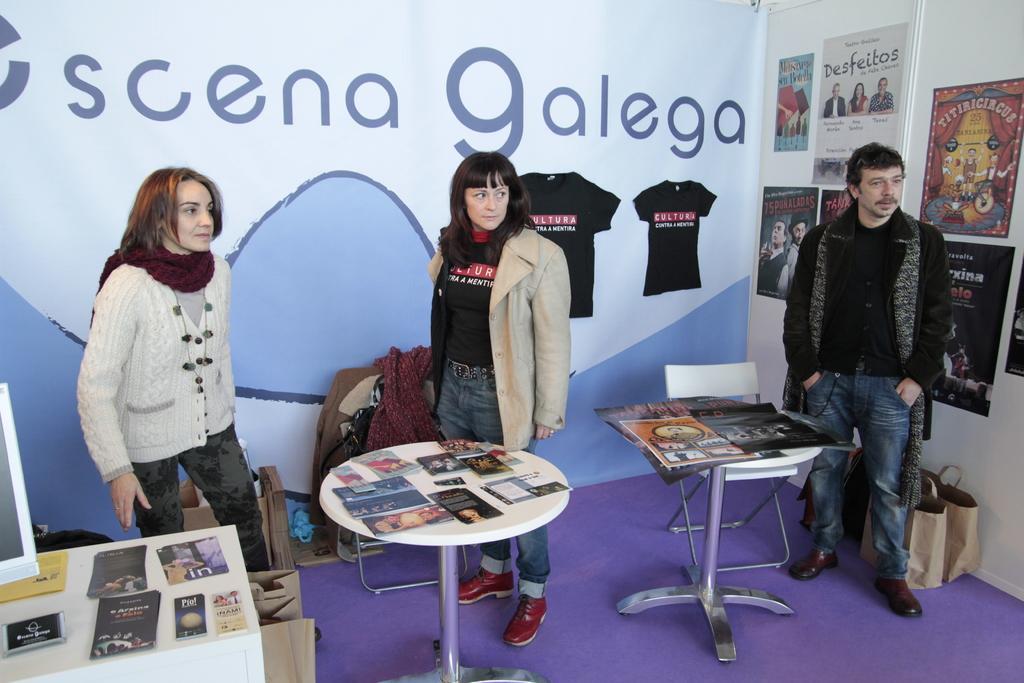Please provide a concise description of this image. In this picture we can see three persons standing on the floor. These are the tables. On the table there are some papers. On the background there is a banner. This is the wall and there are many posters on the wall. 